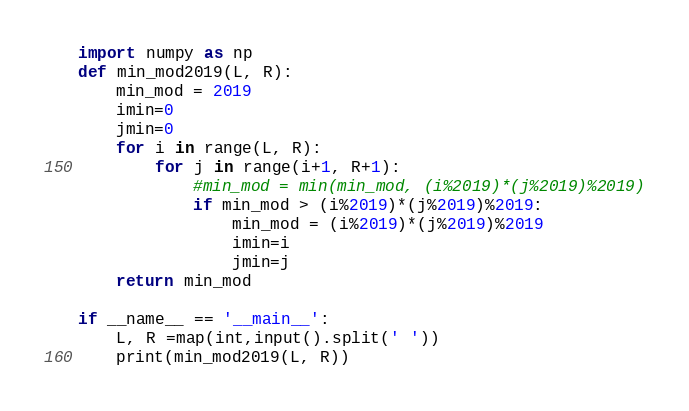<code> <loc_0><loc_0><loc_500><loc_500><_Python_>import numpy as np
def min_mod2019(L, R):
    min_mod = 2019
    imin=0
    jmin=0
    for i in range(L, R):
        for j in range(i+1, R+1):
            #min_mod = min(min_mod, (i%2019)*(j%2019)%2019)
            if min_mod > (i%2019)*(j%2019)%2019:
                min_mod = (i%2019)*(j%2019)%2019
                imin=i
                jmin=j
    return min_mod

if __name__ == '__main__':
    L, R =map(int,input().split(' '))
    print(min_mod2019(L, R))</code> 